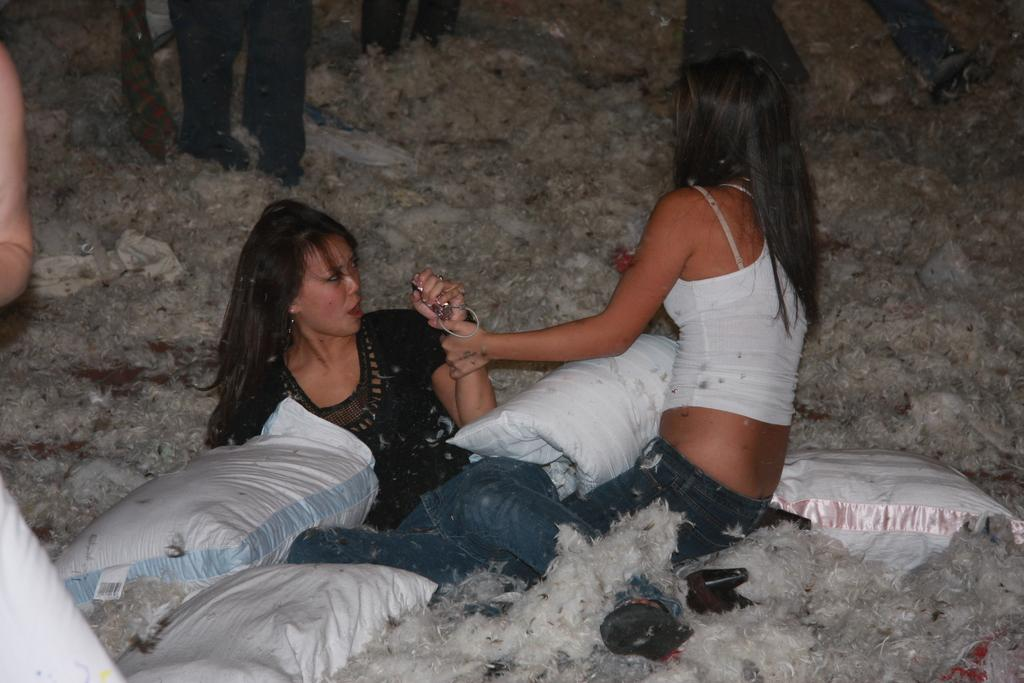Who or what can be seen in the image? There are people in the image. What objects are present in the image? There are bags in the image. Can you describe a unique animal in the image? There is a white-colored skunk in the image. What type of hill can be seen in the background of the image? There is no hill visible in the image. 